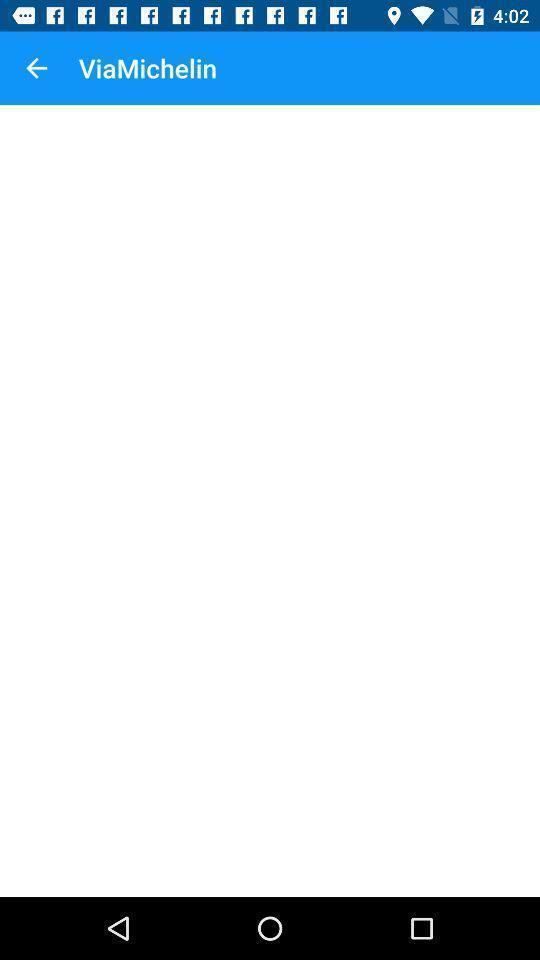Provide a description of this screenshot. Social app for real time 3d mapping and gps. 